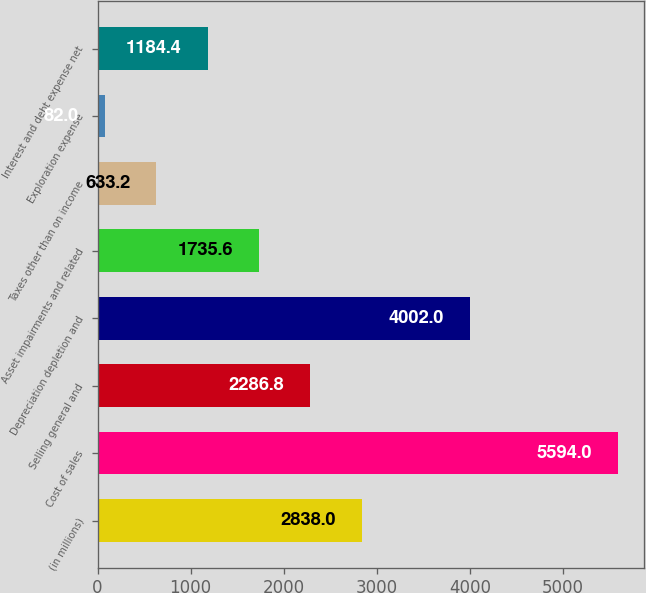<chart> <loc_0><loc_0><loc_500><loc_500><bar_chart><fcel>(in millions)<fcel>Cost of sales<fcel>Selling general and<fcel>Depreciation depletion and<fcel>Asset impairments and related<fcel>Taxes other than on income<fcel>Exploration expense<fcel>Interest and debt expense net<nl><fcel>2838<fcel>5594<fcel>2286.8<fcel>4002<fcel>1735.6<fcel>633.2<fcel>82<fcel>1184.4<nl></chart> 